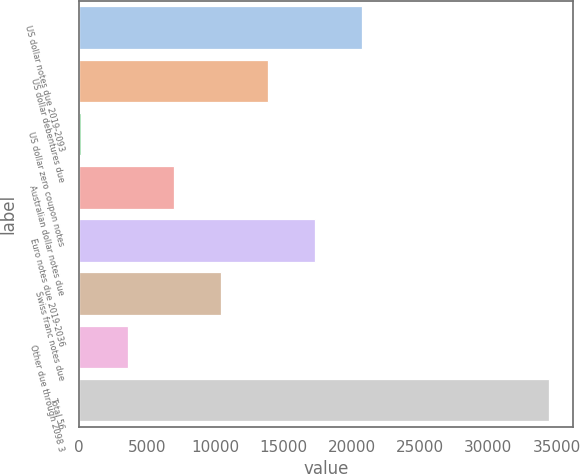<chart> <loc_0><loc_0><loc_500><loc_500><bar_chart><fcel>US dollar notes due 2019-2093<fcel>US dollar debentures due<fcel>US dollar zero coupon notes<fcel>Australian dollar notes due<fcel>Euro notes due 2019-2036<fcel>Swiss franc notes due<fcel>Other due through 2098 3<fcel>Total 56<nl><fcel>20751.2<fcel>13886.8<fcel>158<fcel>7022.4<fcel>17319<fcel>10454.6<fcel>3590.2<fcel>34480<nl></chart> 